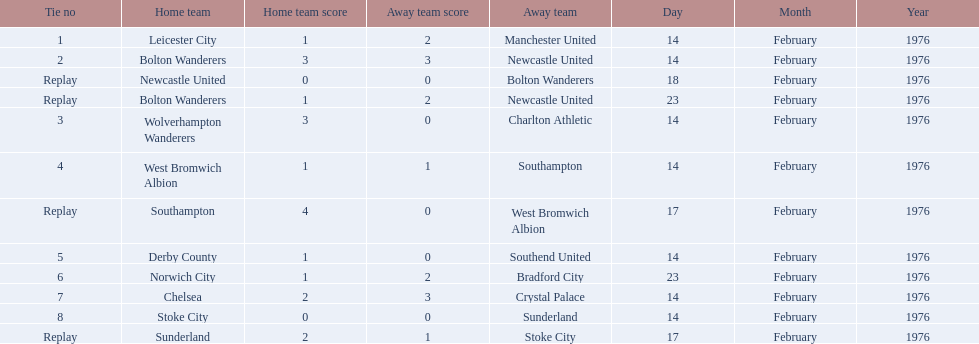Who were all the teams that played? Leicester City, Manchester United, Bolton Wanderers, Newcastle United, Newcastle United, Bolton Wanderers, Bolton Wanderers, Newcastle United, Wolverhampton Wanderers, Charlton Athletic, West Bromwich Albion, Southampton, Southampton, West Bromwich Albion, Derby County, Southend United, Norwich City, Bradford City, Chelsea, Crystal Palace, Stoke City, Sunderland, Sunderland, Stoke City. Which of these teams won? Manchester United, Newcastle United, Wolverhampton Wanderers, Southampton, Derby County, Bradford City, Crystal Palace, Sunderland. What was manchester united's winning score? 1–2. What was the wolverhampton wonders winning score? 3–0. Which of these two teams had the better winning score? Wolverhampton Wanderers. 